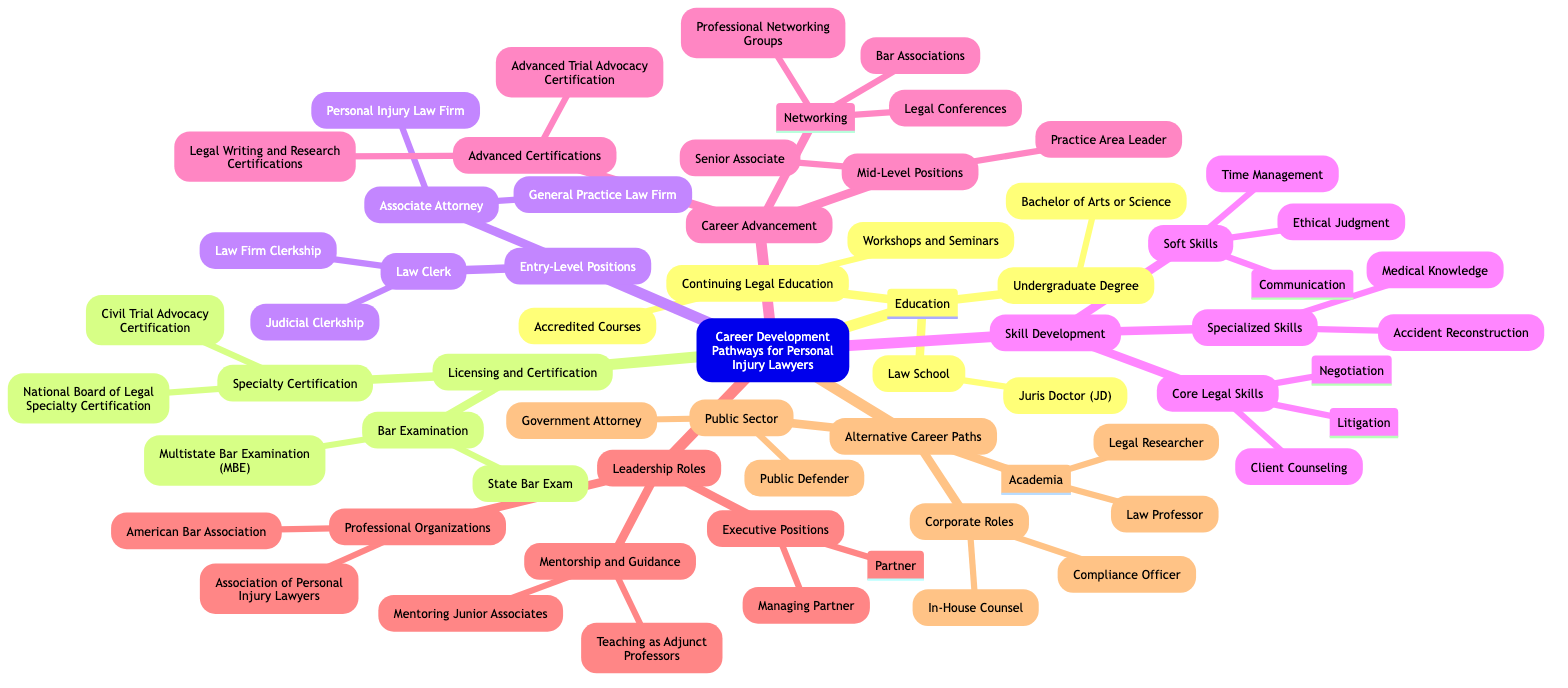What are the two types of education listed? The diagram lists three education-related nodes but requests two types. "Undergraduate Degree" and "Law School" are two distinct categories of education included within the broader Education node.
Answer: Undergraduate Degree, Law School How many types of licenses or certifications are identified in the diagram? The Licensing and Certification section has two main categories: Bar Examination and Specialty Certification. Each category contains separate elements, but the question asks for the number of main types, which is two.
Answer: 2 What type of ongoing education is mentioned under Continuing Legal Education? Continuing Legal Education includes two categories in the diagram: Accredited Courses and Workshops and Seminars. Since the question asks for the general type, either of these terms could be valid to describe the ongoing education, but they fall again under the Continuing Legal Education category.
Answer: Accredited Courses, Workshops and Seminars Which leadership position is identified as an executive role in the diagram? The "Executive Positions" category under Leadership Roles identifies two specific titles, with "Partner" being one of them. It is specifically noted as an executive-level role for personal injury lawyers advancing their careers.
Answer: Partner What specialized skill focuses on understanding medical aspects? Within the Skill Development section, specifically the specialized skills part, "Medical Knowledge" is listed as a skill directly relevant to personal injury law practice. Hence, the answer relates to the ability to understand medical implications.
Answer: Medical Knowledge What type of organizations does the diagram mention under Professional Organizations? The diagram lists two specific organizations within the Professional Organizations section: "American Bar Association" and "Association of Personal Injury Lawyers." The answer relates to professional memberships relevant to personal injury lawyers.
Answer: American Bar Association, Association of Personal Injury Lawyers How many types of entry-level positions are depicted? Under the Entry-Level Positions section, there are two major categories: Law Clerk and Associate Attorney. Each of these categories includes further subdivisions, but the core question asks how many distinct entry-level categories are shown.
Answer: 2 What are the two roles mentioned under Alternative Career Paths? The Alternative Career Paths section is comprised of three main subsections. Each subsection identifies multiple roles; however, the question could focus on any two roles provided in that section. Examples include "Public Defender" and "In-House Counsel," highlighting varying career trajectories for personal injury lawyers outside traditional practice.
Answer: Public Defender, In-House Counsel 